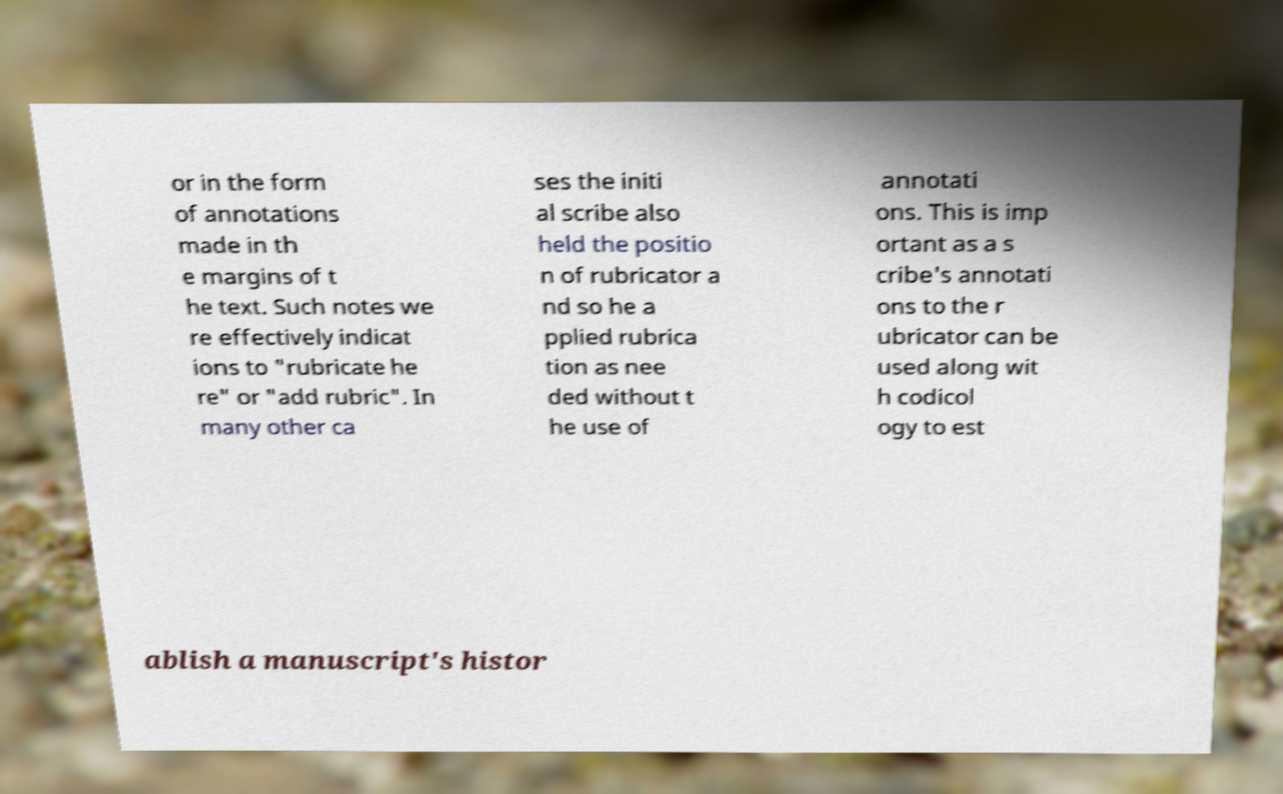For documentation purposes, I need the text within this image transcribed. Could you provide that? or in the form of annotations made in th e margins of t he text. Such notes we re effectively indicat ions to "rubricate he re" or "add rubric". In many other ca ses the initi al scribe also held the positio n of rubricator a nd so he a pplied rubrica tion as nee ded without t he use of annotati ons. This is imp ortant as a s cribe's annotati ons to the r ubricator can be used along wit h codicol ogy to est ablish a manuscript's histor 